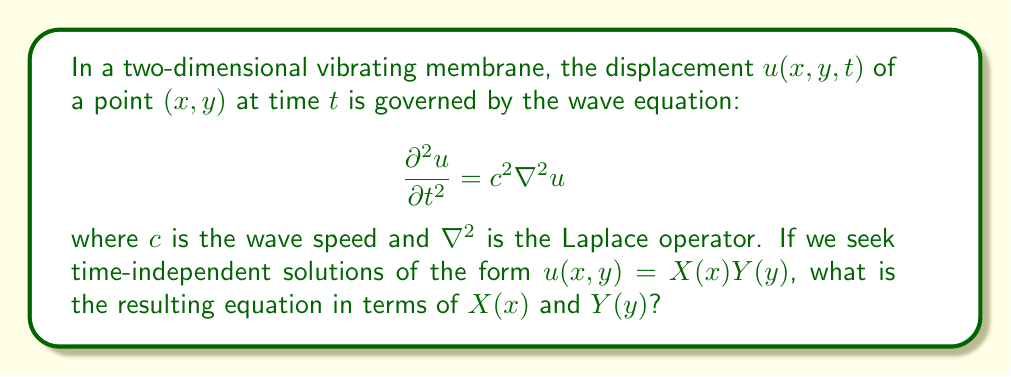Could you help me with this problem? Let's approach this step-by-step:

1) The Laplace operator in 2D is given by:

   $$\nabla^2 = \frac{\partial^2}{\partial x^2} + \frac{\partial^2}{\partial y^2}$$

2) We're looking for time-independent solutions, so $\frac{\partial^2 u}{\partial t^2} = 0$. The wave equation becomes:

   $$0 = c^2 \nabla^2 u$$

3) Substituting $u(x,y) = X(x)Y(y)$ into this equation:

   $$0 = c^2 \left(\frac{\partial^2}{\partial x^2} + \frac{\partial^2}{\partial y^2}\right)(X(x)Y(y))$$

4) Applying the product rule:

   $$0 = c^2 \left(Y(y)\frac{d^2X}{dx^2} + X(x)\frac{d^2Y}{dy^2}\right)$$

5) Dividing both sides by $c^2X(x)Y(y)$:

   $$0 = \frac{1}{X}\frac{d^2X}{dx^2} + \frac{1}{Y}\frac{d^2Y}{dy^2}$$

6) For this equation to hold for all $x$ and $y$, each term must be constant. Let's call this constant $-k^2$:

   $$\frac{1}{X}\frac{d^2X}{dx^2} = -k^2$$
   $$\frac{1}{Y}\frac{d^2Y}{dy^2} = k^2$$

7) These equations can be rewritten as:

   $$\frac{d^2X}{dx^2} + k^2X = 0$$
   $$\frac{d^2Y}{dy^2} - k^2Y = 0$$

This is the resulting system of equations in terms of $X(x)$ and $Y(y)$.
Answer: $$\frac{d^2X}{dx^2} + k^2X = 0, \quad \frac{d^2Y}{dy^2} - k^2Y = 0$$ 